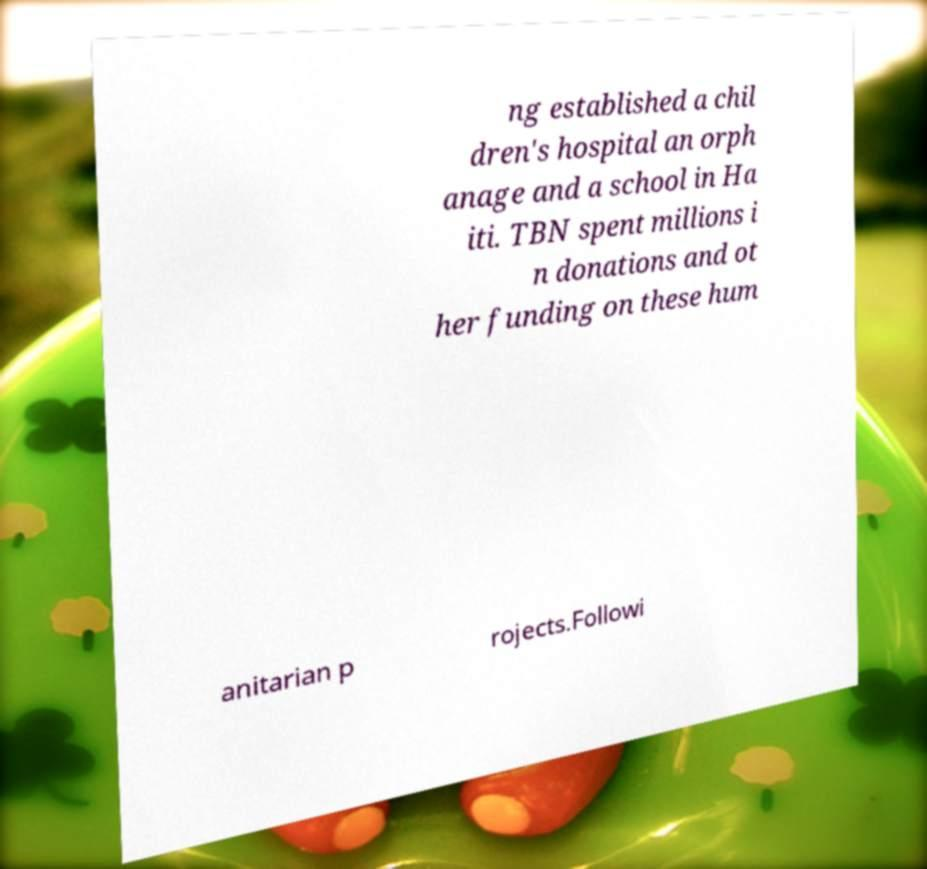What messages or text are displayed in this image? I need them in a readable, typed format. ng established a chil dren's hospital an orph anage and a school in Ha iti. TBN spent millions i n donations and ot her funding on these hum anitarian p rojects.Followi 